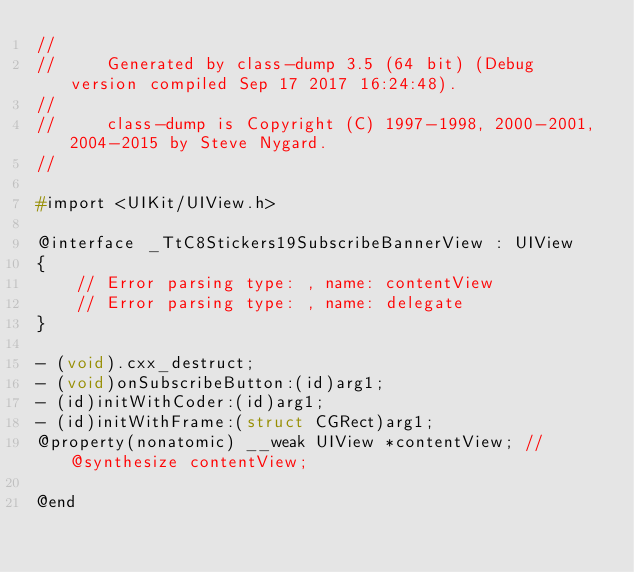<code> <loc_0><loc_0><loc_500><loc_500><_C_>//
//     Generated by class-dump 3.5 (64 bit) (Debug version compiled Sep 17 2017 16:24:48).
//
//     class-dump is Copyright (C) 1997-1998, 2000-2001, 2004-2015 by Steve Nygard.
//

#import <UIKit/UIView.h>

@interface _TtC8Stickers19SubscribeBannerView : UIView
{
    // Error parsing type: , name: contentView
    // Error parsing type: , name: delegate
}

- (void).cxx_destruct;
- (void)onSubscribeButton:(id)arg1;
- (id)initWithCoder:(id)arg1;
- (id)initWithFrame:(struct CGRect)arg1;
@property(nonatomic) __weak UIView *contentView; // @synthesize contentView;

@end

</code> 